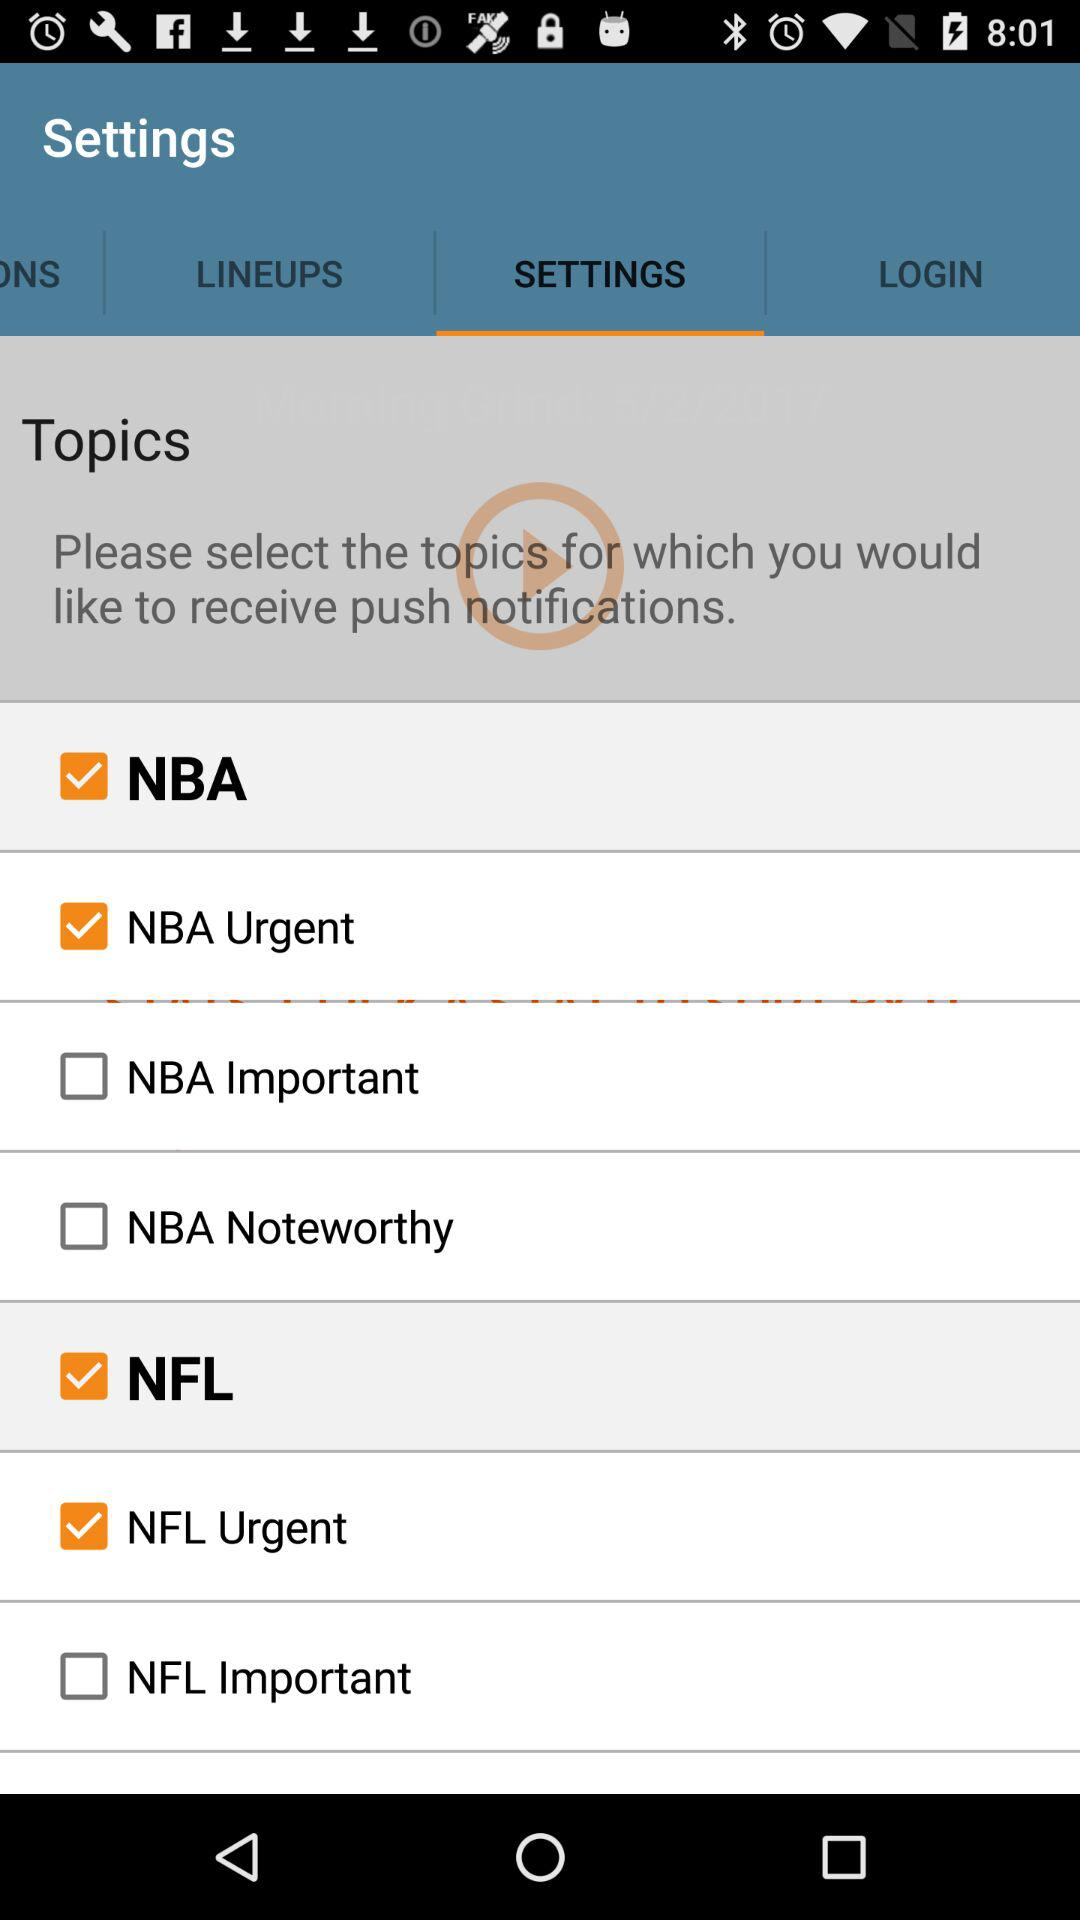What is the current status of the NFL? The current status is on. 